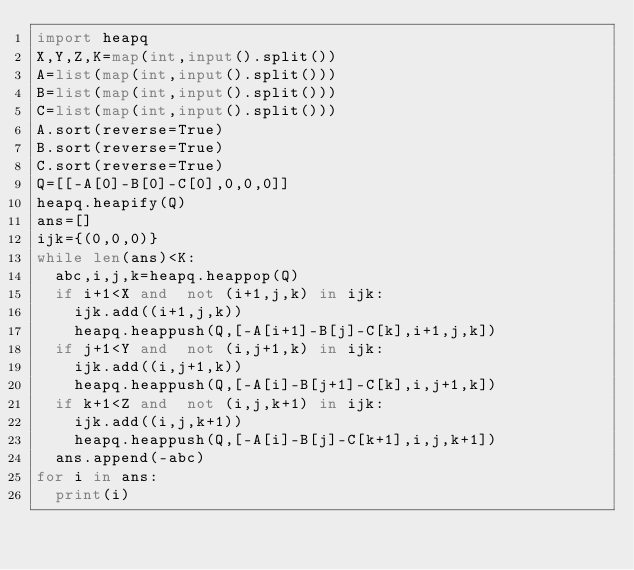Convert code to text. <code><loc_0><loc_0><loc_500><loc_500><_Python_>import heapq
X,Y,Z,K=map(int,input().split())
A=list(map(int,input().split()))
B=list(map(int,input().split()))
C=list(map(int,input().split()))
A.sort(reverse=True)
B.sort(reverse=True)
C.sort(reverse=True)
Q=[[-A[0]-B[0]-C[0],0,0,0]]
heapq.heapify(Q)
ans=[]
ijk={(0,0,0)}
while len(ans)<K:
  abc,i,j,k=heapq.heappop(Q)
  if i+1<X and  not (i+1,j,k) in ijk:
    ijk.add((i+1,j,k))
    heapq.heappush(Q,[-A[i+1]-B[j]-C[k],i+1,j,k])
  if j+1<Y and  not (i,j+1,k) in ijk:
    ijk.add((i,j+1,k))
    heapq.heappush(Q,[-A[i]-B[j+1]-C[k],i,j+1,k])
  if k+1<Z and  not (i,j,k+1) in ijk:
    ijk.add((i,j,k+1))
    heapq.heappush(Q,[-A[i]-B[j]-C[k+1],i,j,k+1])
  ans.append(-abc)
for i in ans:
  print(i)</code> 